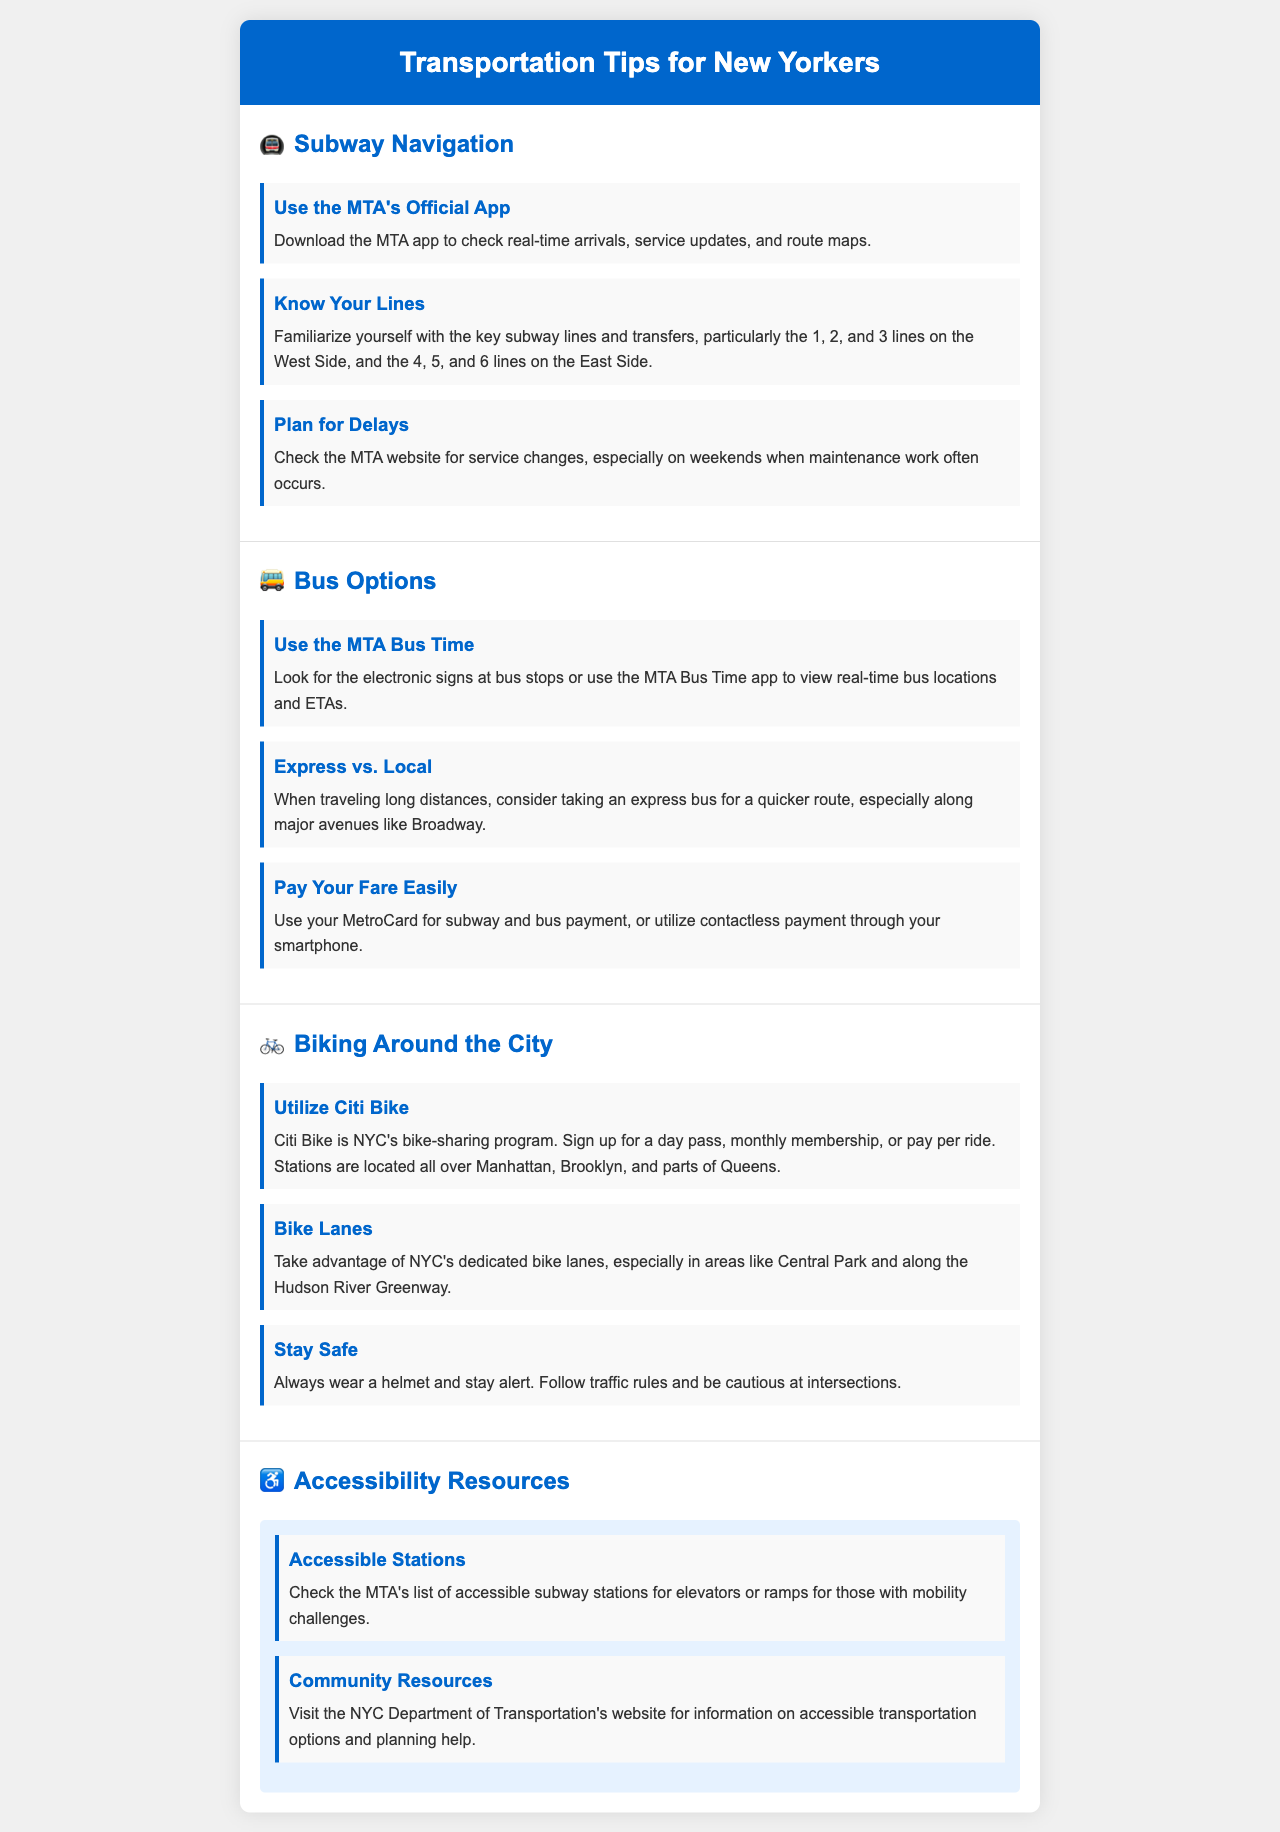What is the title of the brochure? The title of the brochure is clearly stated in the header section, which is "Transportation Tips for New Yorkers."
Answer: Transportation Tips for New Yorkers What app should you download for subway navigation? The brochure mentions downloading the MTA app for real-time arrivals, service updates, and route maps.
Answer: MTA app Which lines are highlighted in the subway navigation section? The document specifies key subway lines: the 1, 2, and 3 lines on the West Side, and the 4, 5, and 6 lines on the East Side.
Answer: 1, 2, 3, 4, 5, 6 What is the name of NYC's bike-sharing program? The brochure refers to the bike-sharing program as Citi Bike.
Answer: Citi Bike Which safety measure is recommended for biking? The document emphasizes the importance of wearing a helmet as a safety measure for biking.
Answer: Wear a helmet How can you check real-time bus locations? According to the brochure, you can use the MTA Bus Time app or look for electronic signs at bus stops to check real-time bus locations.
Answer: MTA Bus Time app What is one way to make fare payment easier? The brochure suggests using a MetroCard for subway and bus payment as an easy way to pay your fare.
Answer: MetroCard Which section of the brochure provides resources for accessibility? The brochure features a dedicated section titled "Accessibility Resources" that gives information on accessible transportation options.
Answer: Accessibility Resources How can you find accessible subway stations? The MTA's list of accessible subway stations can be checked for information about elevators or ramps.
Answer: MTA's list 